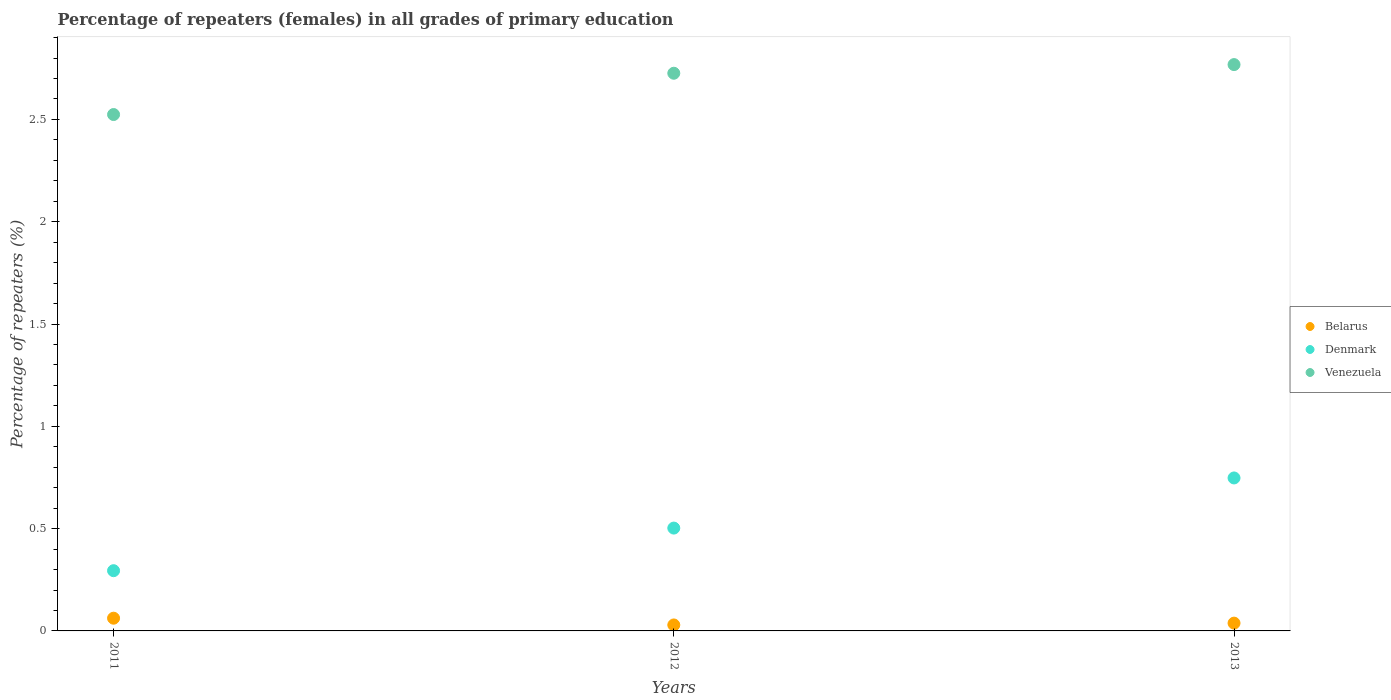How many different coloured dotlines are there?
Provide a succinct answer. 3. Is the number of dotlines equal to the number of legend labels?
Provide a short and direct response. Yes. What is the percentage of repeaters (females) in Venezuela in 2013?
Ensure brevity in your answer.  2.77. Across all years, what is the maximum percentage of repeaters (females) in Venezuela?
Ensure brevity in your answer.  2.77. Across all years, what is the minimum percentage of repeaters (females) in Denmark?
Ensure brevity in your answer.  0.29. In which year was the percentage of repeaters (females) in Denmark maximum?
Ensure brevity in your answer.  2013. In which year was the percentage of repeaters (females) in Denmark minimum?
Your answer should be very brief. 2011. What is the total percentage of repeaters (females) in Venezuela in the graph?
Provide a short and direct response. 8.02. What is the difference between the percentage of repeaters (females) in Denmark in 2011 and that in 2012?
Your response must be concise. -0.21. What is the difference between the percentage of repeaters (females) in Venezuela in 2011 and the percentage of repeaters (females) in Belarus in 2013?
Give a very brief answer. 2.49. What is the average percentage of repeaters (females) in Denmark per year?
Keep it short and to the point. 0.51. In the year 2012, what is the difference between the percentage of repeaters (females) in Venezuela and percentage of repeaters (females) in Belarus?
Give a very brief answer. 2.7. What is the ratio of the percentage of repeaters (females) in Venezuela in 2011 to that in 2012?
Your answer should be compact. 0.93. Is the percentage of repeaters (females) in Denmark in 2012 less than that in 2013?
Make the answer very short. Yes. What is the difference between the highest and the second highest percentage of repeaters (females) in Denmark?
Your answer should be compact. 0.25. What is the difference between the highest and the lowest percentage of repeaters (females) in Belarus?
Ensure brevity in your answer.  0.03. Is the sum of the percentage of repeaters (females) in Venezuela in 2012 and 2013 greater than the maximum percentage of repeaters (females) in Denmark across all years?
Offer a very short reply. Yes. Is the percentage of repeaters (females) in Belarus strictly less than the percentage of repeaters (females) in Venezuela over the years?
Keep it short and to the point. Yes. How many dotlines are there?
Keep it short and to the point. 3. How many years are there in the graph?
Offer a very short reply. 3. Are the values on the major ticks of Y-axis written in scientific E-notation?
Provide a succinct answer. No. Does the graph contain grids?
Give a very brief answer. No. How many legend labels are there?
Offer a terse response. 3. How are the legend labels stacked?
Give a very brief answer. Vertical. What is the title of the graph?
Give a very brief answer. Percentage of repeaters (females) in all grades of primary education. Does "Suriname" appear as one of the legend labels in the graph?
Keep it short and to the point. No. What is the label or title of the Y-axis?
Make the answer very short. Percentage of repeaters (%). What is the Percentage of repeaters (%) of Belarus in 2011?
Provide a succinct answer. 0.06. What is the Percentage of repeaters (%) in Denmark in 2011?
Your answer should be very brief. 0.29. What is the Percentage of repeaters (%) of Venezuela in 2011?
Ensure brevity in your answer.  2.52. What is the Percentage of repeaters (%) of Belarus in 2012?
Your answer should be very brief. 0.03. What is the Percentage of repeaters (%) of Denmark in 2012?
Provide a short and direct response. 0.5. What is the Percentage of repeaters (%) in Venezuela in 2012?
Offer a very short reply. 2.73. What is the Percentage of repeaters (%) in Belarus in 2013?
Give a very brief answer. 0.04. What is the Percentage of repeaters (%) of Denmark in 2013?
Make the answer very short. 0.75. What is the Percentage of repeaters (%) in Venezuela in 2013?
Your answer should be compact. 2.77. Across all years, what is the maximum Percentage of repeaters (%) of Belarus?
Provide a succinct answer. 0.06. Across all years, what is the maximum Percentage of repeaters (%) in Denmark?
Give a very brief answer. 0.75. Across all years, what is the maximum Percentage of repeaters (%) in Venezuela?
Give a very brief answer. 2.77. Across all years, what is the minimum Percentage of repeaters (%) of Belarus?
Provide a succinct answer. 0.03. Across all years, what is the minimum Percentage of repeaters (%) in Denmark?
Your answer should be compact. 0.29. Across all years, what is the minimum Percentage of repeaters (%) in Venezuela?
Your answer should be compact. 2.52. What is the total Percentage of repeaters (%) in Belarus in the graph?
Keep it short and to the point. 0.13. What is the total Percentage of repeaters (%) of Denmark in the graph?
Your answer should be very brief. 1.54. What is the total Percentage of repeaters (%) of Venezuela in the graph?
Offer a very short reply. 8.02. What is the difference between the Percentage of repeaters (%) of Belarus in 2011 and that in 2012?
Give a very brief answer. 0.03. What is the difference between the Percentage of repeaters (%) of Denmark in 2011 and that in 2012?
Provide a short and direct response. -0.21. What is the difference between the Percentage of repeaters (%) in Venezuela in 2011 and that in 2012?
Your answer should be compact. -0.2. What is the difference between the Percentage of repeaters (%) of Belarus in 2011 and that in 2013?
Make the answer very short. 0.02. What is the difference between the Percentage of repeaters (%) of Denmark in 2011 and that in 2013?
Your response must be concise. -0.45. What is the difference between the Percentage of repeaters (%) in Venezuela in 2011 and that in 2013?
Give a very brief answer. -0.24. What is the difference between the Percentage of repeaters (%) in Belarus in 2012 and that in 2013?
Your response must be concise. -0.01. What is the difference between the Percentage of repeaters (%) in Denmark in 2012 and that in 2013?
Give a very brief answer. -0.24. What is the difference between the Percentage of repeaters (%) in Venezuela in 2012 and that in 2013?
Offer a very short reply. -0.04. What is the difference between the Percentage of repeaters (%) in Belarus in 2011 and the Percentage of repeaters (%) in Denmark in 2012?
Your response must be concise. -0.44. What is the difference between the Percentage of repeaters (%) of Belarus in 2011 and the Percentage of repeaters (%) of Venezuela in 2012?
Offer a terse response. -2.66. What is the difference between the Percentage of repeaters (%) in Denmark in 2011 and the Percentage of repeaters (%) in Venezuela in 2012?
Ensure brevity in your answer.  -2.43. What is the difference between the Percentage of repeaters (%) of Belarus in 2011 and the Percentage of repeaters (%) of Denmark in 2013?
Your answer should be compact. -0.69. What is the difference between the Percentage of repeaters (%) of Belarus in 2011 and the Percentage of repeaters (%) of Venezuela in 2013?
Keep it short and to the point. -2.71. What is the difference between the Percentage of repeaters (%) of Denmark in 2011 and the Percentage of repeaters (%) of Venezuela in 2013?
Ensure brevity in your answer.  -2.47. What is the difference between the Percentage of repeaters (%) of Belarus in 2012 and the Percentage of repeaters (%) of Denmark in 2013?
Make the answer very short. -0.72. What is the difference between the Percentage of repeaters (%) in Belarus in 2012 and the Percentage of repeaters (%) in Venezuela in 2013?
Keep it short and to the point. -2.74. What is the difference between the Percentage of repeaters (%) of Denmark in 2012 and the Percentage of repeaters (%) of Venezuela in 2013?
Your answer should be compact. -2.27. What is the average Percentage of repeaters (%) of Belarus per year?
Make the answer very short. 0.04. What is the average Percentage of repeaters (%) in Denmark per year?
Your response must be concise. 0.51. What is the average Percentage of repeaters (%) of Venezuela per year?
Your answer should be compact. 2.67. In the year 2011, what is the difference between the Percentage of repeaters (%) of Belarus and Percentage of repeaters (%) of Denmark?
Offer a very short reply. -0.23. In the year 2011, what is the difference between the Percentage of repeaters (%) of Belarus and Percentage of repeaters (%) of Venezuela?
Offer a terse response. -2.46. In the year 2011, what is the difference between the Percentage of repeaters (%) of Denmark and Percentage of repeaters (%) of Venezuela?
Your answer should be very brief. -2.23. In the year 2012, what is the difference between the Percentage of repeaters (%) of Belarus and Percentage of repeaters (%) of Denmark?
Give a very brief answer. -0.47. In the year 2012, what is the difference between the Percentage of repeaters (%) in Belarus and Percentage of repeaters (%) in Venezuela?
Offer a very short reply. -2.7. In the year 2012, what is the difference between the Percentage of repeaters (%) of Denmark and Percentage of repeaters (%) of Venezuela?
Ensure brevity in your answer.  -2.22. In the year 2013, what is the difference between the Percentage of repeaters (%) of Belarus and Percentage of repeaters (%) of Denmark?
Ensure brevity in your answer.  -0.71. In the year 2013, what is the difference between the Percentage of repeaters (%) in Belarus and Percentage of repeaters (%) in Venezuela?
Your response must be concise. -2.73. In the year 2013, what is the difference between the Percentage of repeaters (%) in Denmark and Percentage of repeaters (%) in Venezuela?
Your answer should be compact. -2.02. What is the ratio of the Percentage of repeaters (%) in Belarus in 2011 to that in 2012?
Provide a short and direct response. 2.13. What is the ratio of the Percentage of repeaters (%) of Denmark in 2011 to that in 2012?
Offer a very short reply. 0.59. What is the ratio of the Percentage of repeaters (%) of Venezuela in 2011 to that in 2012?
Your response must be concise. 0.93. What is the ratio of the Percentage of repeaters (%) of Belarus in 2011 to that in 2013?
Provide a short and direct response. 1.63. What is the ratio of the Percentage of repeaters (%) of Denmark in 2011 to that in 2013?
Provide a succinct answer. 0.39. What is the ratio of the Percentage of repeaters (%) of Venezuela in 2011 to that in 2013?
Your answer should be very brief. 0.91. What is the ratio of the Percentage of repeaters (%) in Belarus in 2012 to that in 2013?
Your answer should be very brief. 0.77. What is the ratio of the Percentage of repeaters (%) of Denmark in 2012 to that in 2013?
Your answer should be very brief. 0.67. What is the ratio of the Percentage of repeaters (%) of Venezuela in 2012 to that in 2013?
Keep it short and to the point. 0.98. What is the difference between the highest and the second highest Percentage of repeaters (%) in Belarus?
Your answer should be compact. 0.02. What is the difference between the highest and the second highest Percentage of repeaters (%) in Denmark?
Ensure brevity in your answer.  0.24. What is the difference between the highest and the second highest Percentage of repeaters (%) of Venezuela?
Provide a short and direct response. 0.04. What is the difference between the highest and the lowest Percentage of repeaters (%) in Belarus?
Offer a very short reply. 0.03. What is the difference between the highest and the lowest Percentage of repeaters (%) of Denmark?
Keep it short and to the point. 0.45. What is the difference between the highest and the lowest Percentage of repeaters (%) in Venezuela?
Provide a succinct answer. 0.24. 